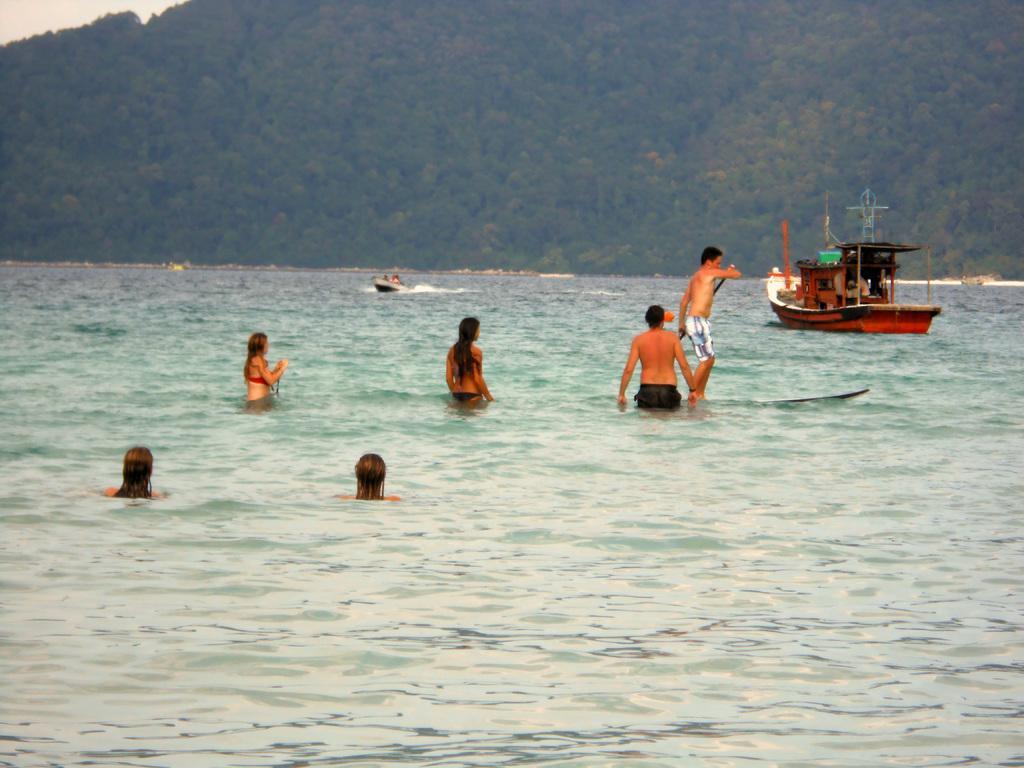In one or two sentences, can you explain what this image depicts? This picture is clicked outside the city. In the center we can see the group of persons in the water body. On the right there is a boat in the water body. In the background we can see the sky, trees and some other objects. 